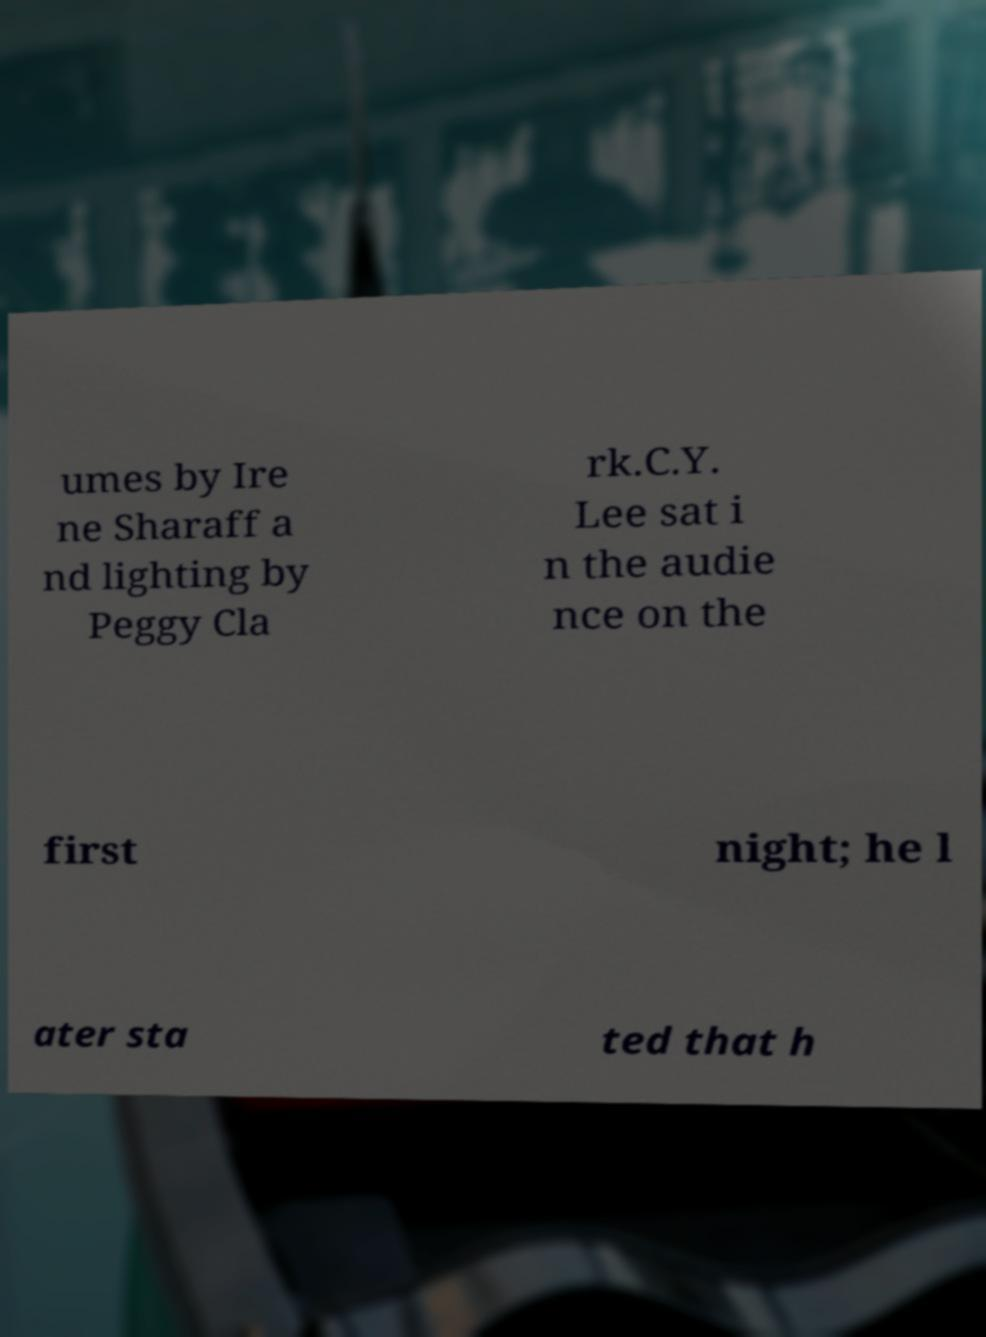Could you assist in decoding the text presented in this image and type it out clearly? umes by Ire ne Sharaff a nd lighting by Peggy Cla rk.C.Y. Lee sat i n the audie nce on the first night; he l ater sta ted that h 